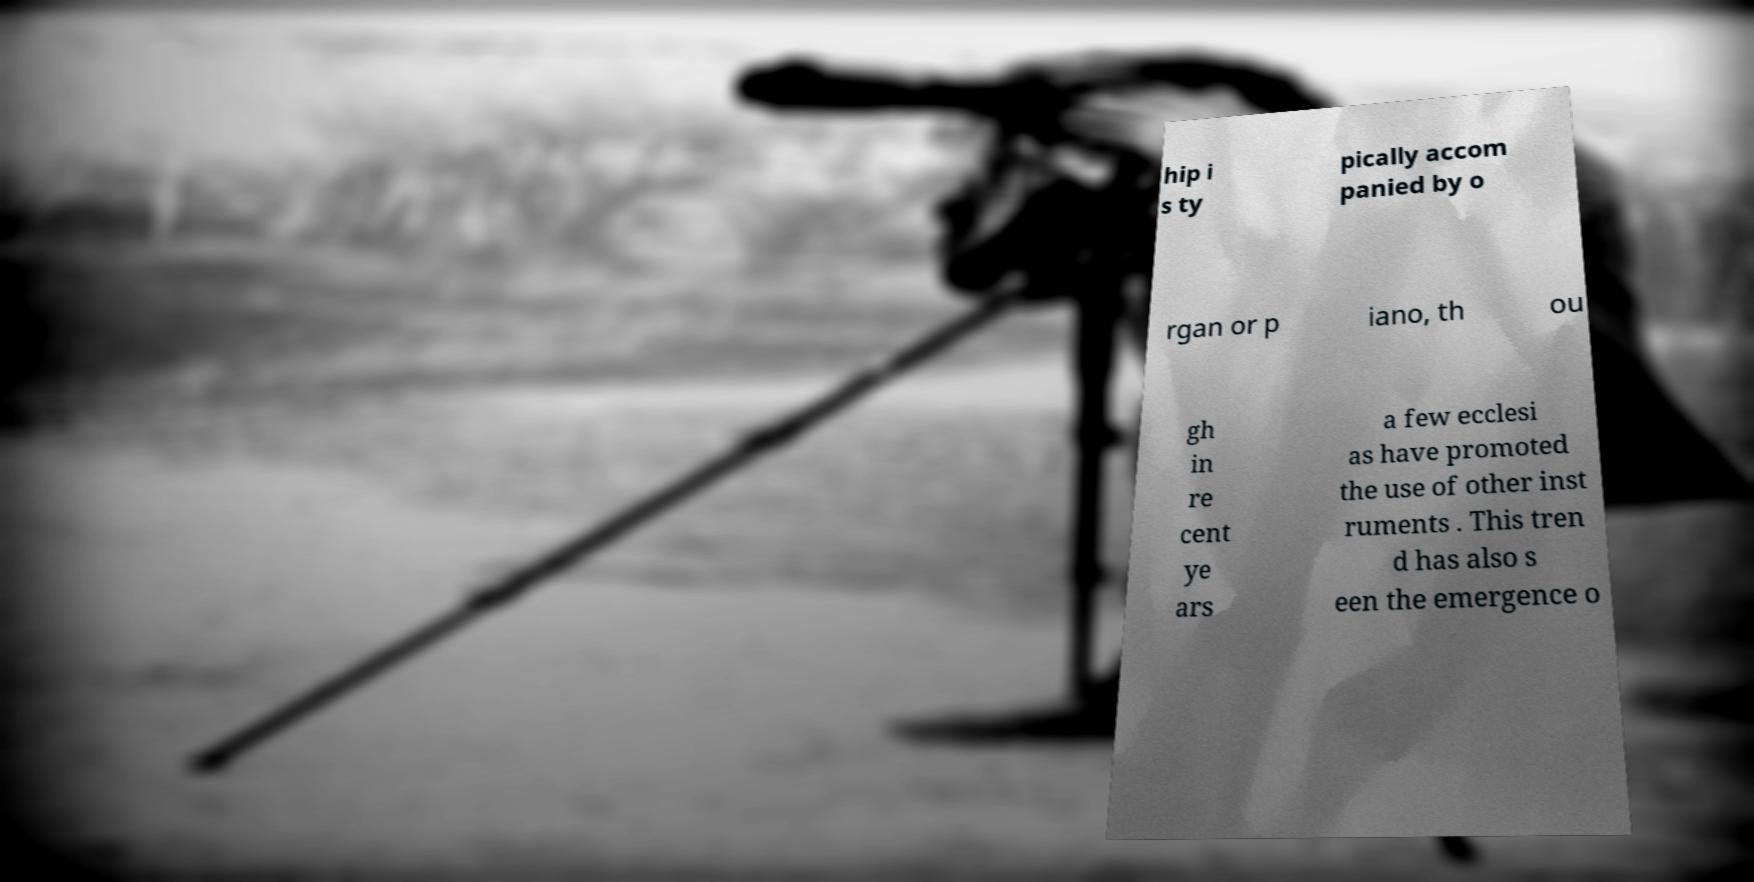Could you extract and type out the text from this image? hip i s ty pically accom panied by o rgan or p iano, th ou gh in re cent ye ars a few ecclesi as have promoted the use of other inst ruments . This tren d has also s een the emergence o 